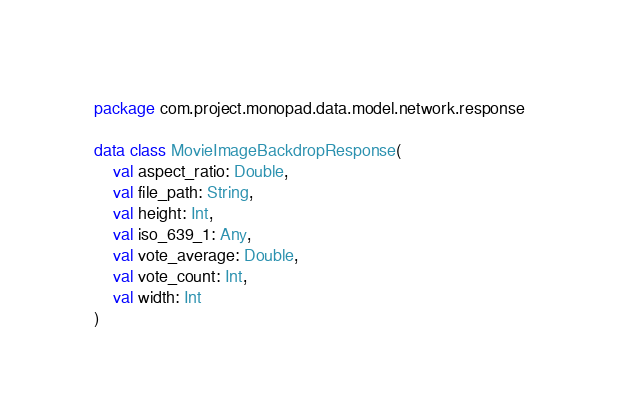<code> <loc_0><loc_0><loc_500><loc_500><_Kotlin_>package com.project.monopad.data.model.network.response

data class MovieImageBackdropResponse(
    val aspect_ratio: Double,
    val file_path: String,
    val height: Int,
    val iso_639_1: Any,
    val vote_average: Double,
    val vote_count: Int,
    val width: Int
)</code> 